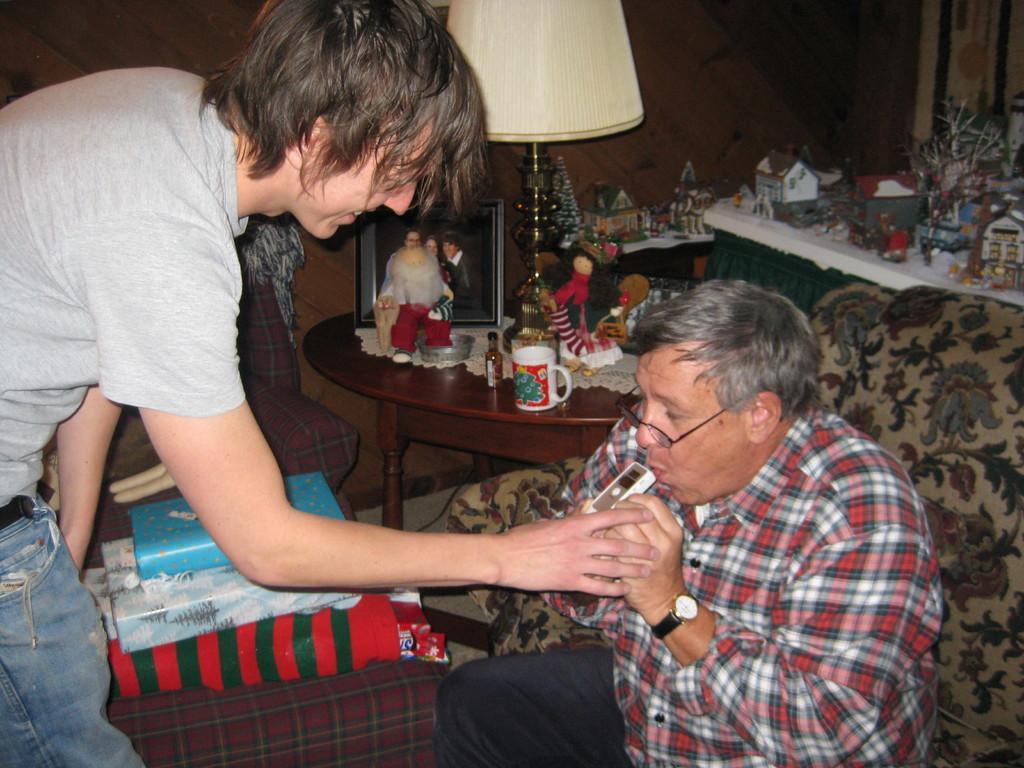Can you describe this image briefly? In this image there are two man, one is sitting on sofa and other bending, in the background there is a table, on that table there are toys, photo frames, table lamps and there is another table, on that there are toys in the background there is a wall. 